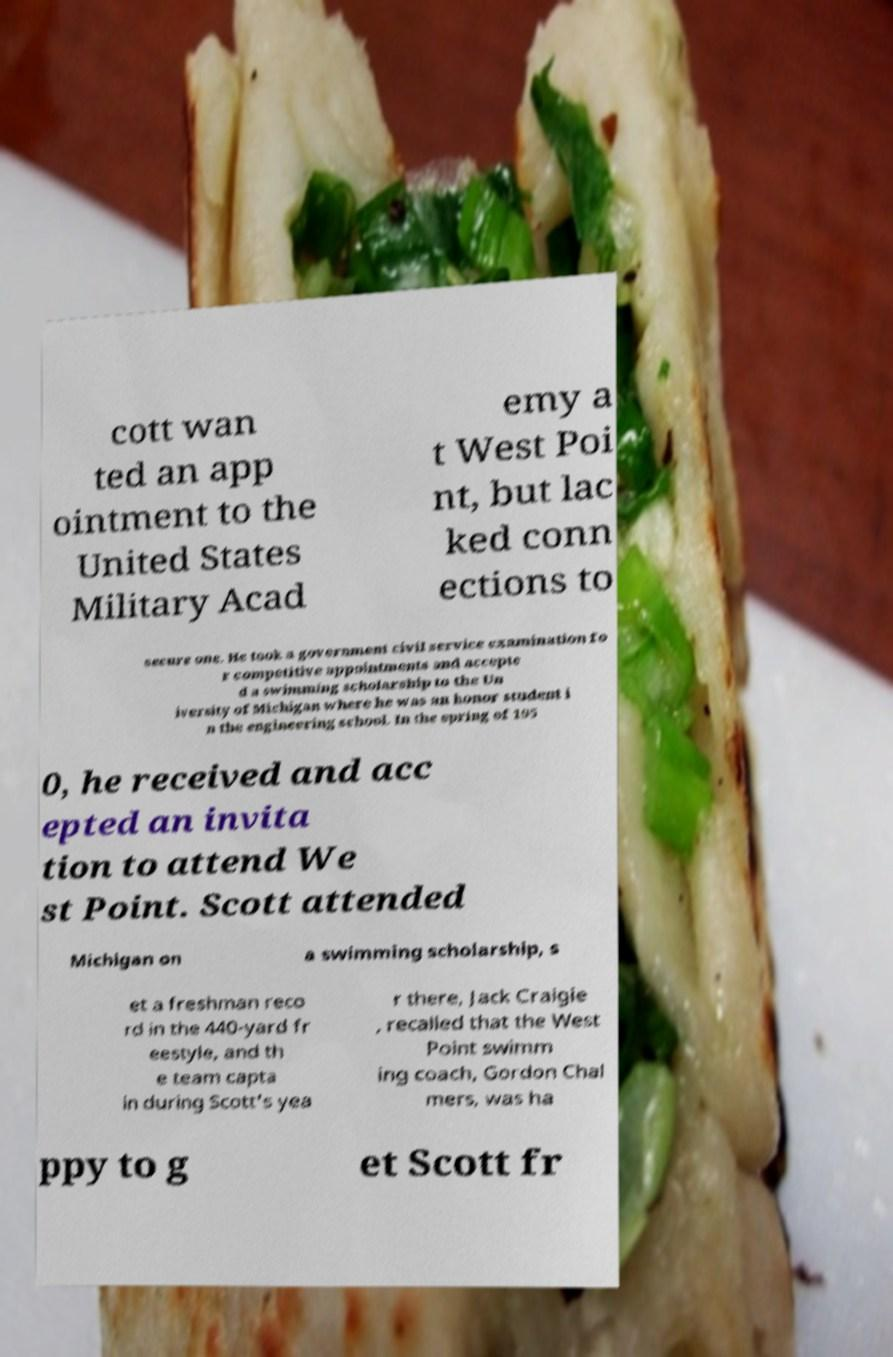What messages or text are displayed in this image? I need them in a readable, typed format. cott wan ted an app ointment to the United States Military Acad emy a t West Poi nt, but lac ked conn ections to secure one. He took a government civil service examination fo r competitive appointments and accepte d a swimming scholarship to the Un iversity of Michigan where he was an honor student i n the engineering school. In the spring of 195 0, he received and acc epted an invita tion to attend We st Point. Scott attended Michigan on a swimming scholarship, s et a freshman reco rd in the 440-yard fr eestyle, and th e team capta in during Scott's yea r there, Jack Craigie , recalled that the West Point swimm ing coach, Gordon Chal mers, was ha ppy to g et Scott fr 